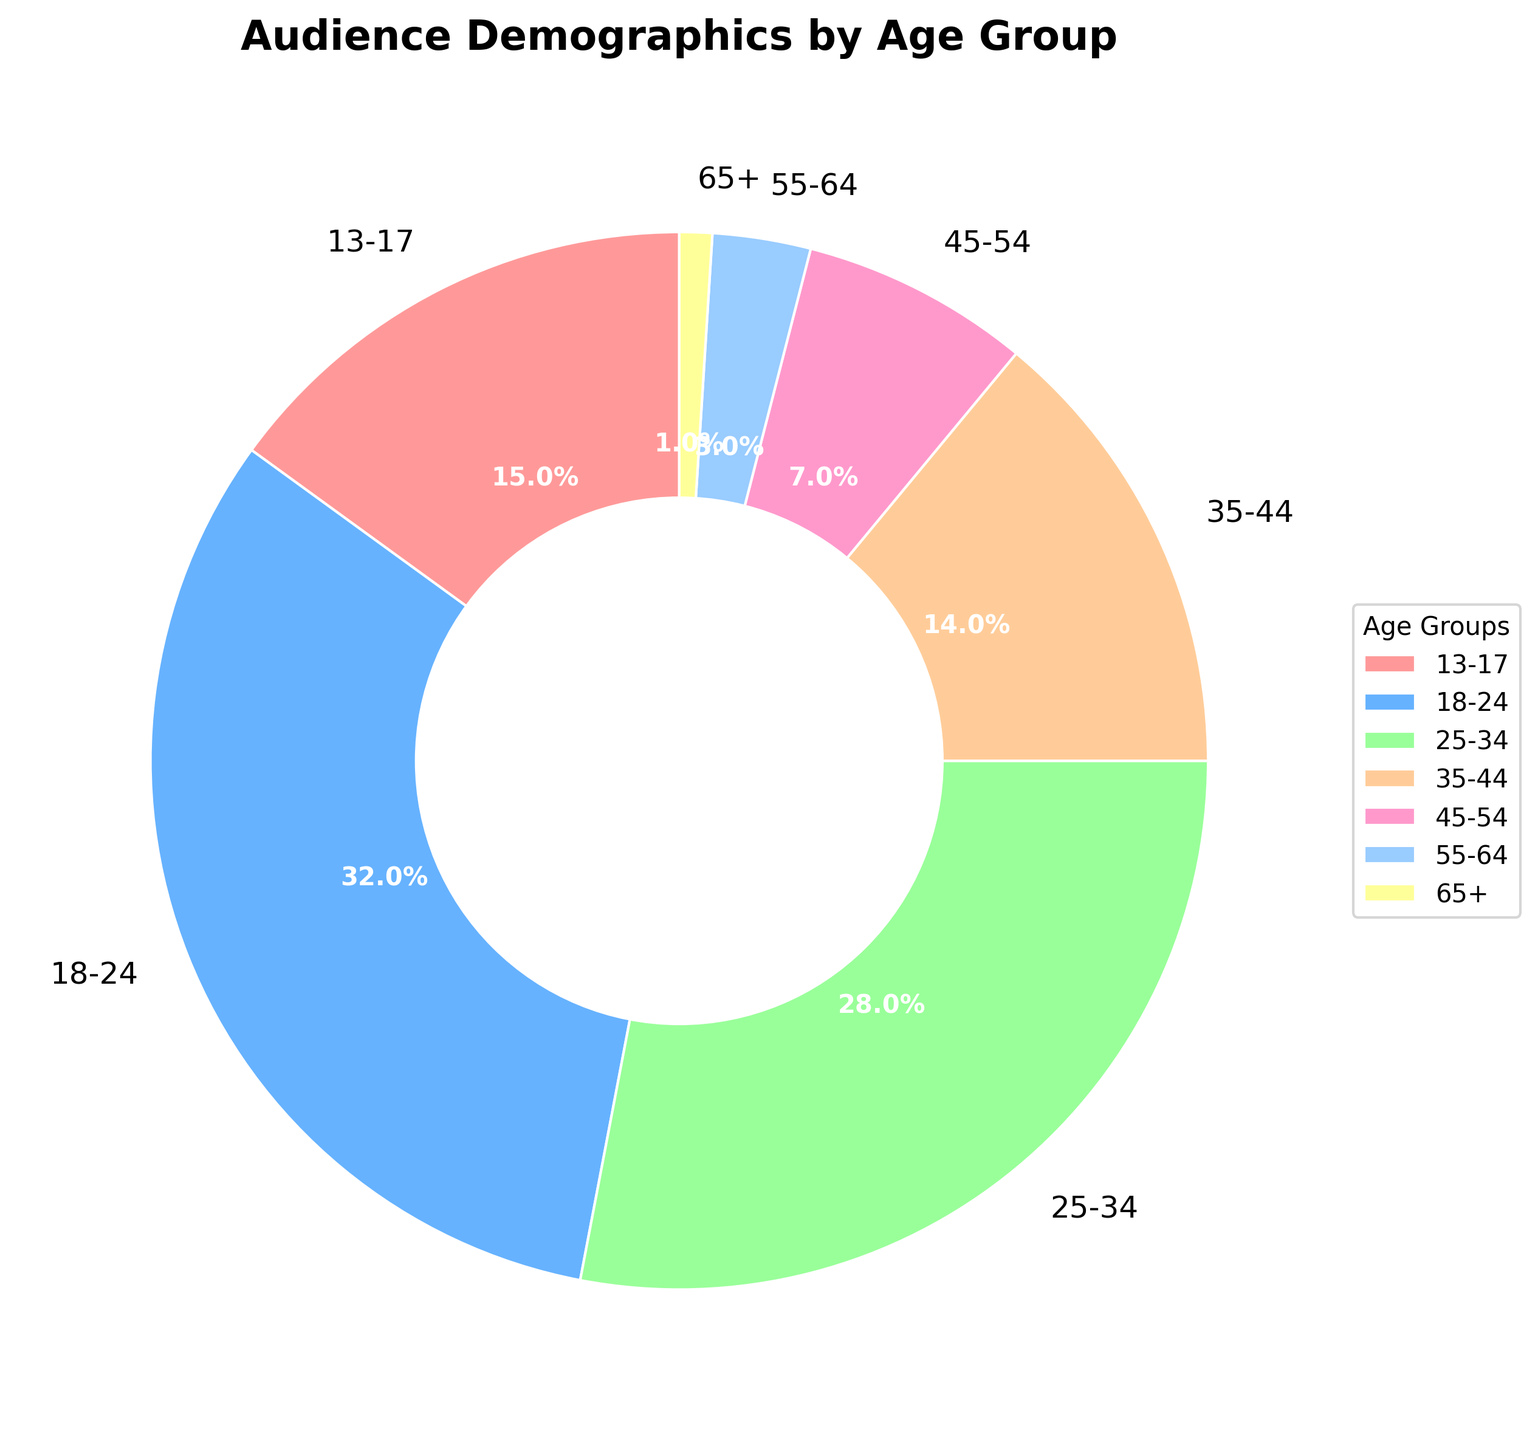What is the age group with the highest percentage? Look at the pie chart and identify the segment that has the largest size. It corresponds to the 18-24 age group, which has a percentage of 32%.
Answer: 18-24 Which two age groups have the same visual segment color but slightly differing sizes? The colors are unique to each age group, so this isn't possible. The visual separation in the pie chart ensures that no two segments share the same color
Answer: None Calculate the total percentage of viewers aged 13-34. Sum the percentages for the age groups 13-17, 18-24, and 25-34: (15% + 32% + 28%) = 75%. This represents the total percentage of viewers in the 13-34 age bracket.
Answer: 75% What is the percentage difference between the 35-44 age group and the 18-24 age group? Subtract the percentage of the 35-44 age group from the 18-24 age group: (32% - 14%) = 18%. So, the 18-24 age group has 18% more viewers than the 35-44 age group.
Answer: 18% Which age group has the smallest percentage of viewers? Examine the pie chart and identify the smallest segment, which corresponds to the 65+ age group at 1%.
Answer: 65+ How does the combined percentage of the 45+ age groups compare to the 18-24 age group? Add the percentages of the 45-54, 55-64, and 65+ age groups: (7% + 3% + 1%) = 11%. Compare this to the 32% of the 18-24 age group. The 18-24 group has a higher percentage by 21 points.
Answer: 18-24 group has 21% higher What percentage of viewers are older than 34 years? Sum the percentages for the age groups 35-44, 45-54, 55-64, and 65+: (14% + 7% + 3% + 1%) = 25%. This represents the total percentage of viewers older than 34 years.
Answer: 25% Which age group is colored green in the pie chart? Identify the green segment based on the chart. This segment represents the 25-34 age group.
Answer: 25-34 Compare the percentage of viewers in the 13-17 age group to those in the 45-54 age group. Which is higher? The 13-17 age group has 15%, while the 45-54 age group has 7%. Therefore, the 13-17 age group has a higher percentage.
Answer: 13-17 What is the combined percentage of viewers aged under 25? Sum the percentages for the age groups 13-17 and 18-24: (15% + 32%) = 47%. This represents the total percentage of viewers under 25.
Answer: 47% 